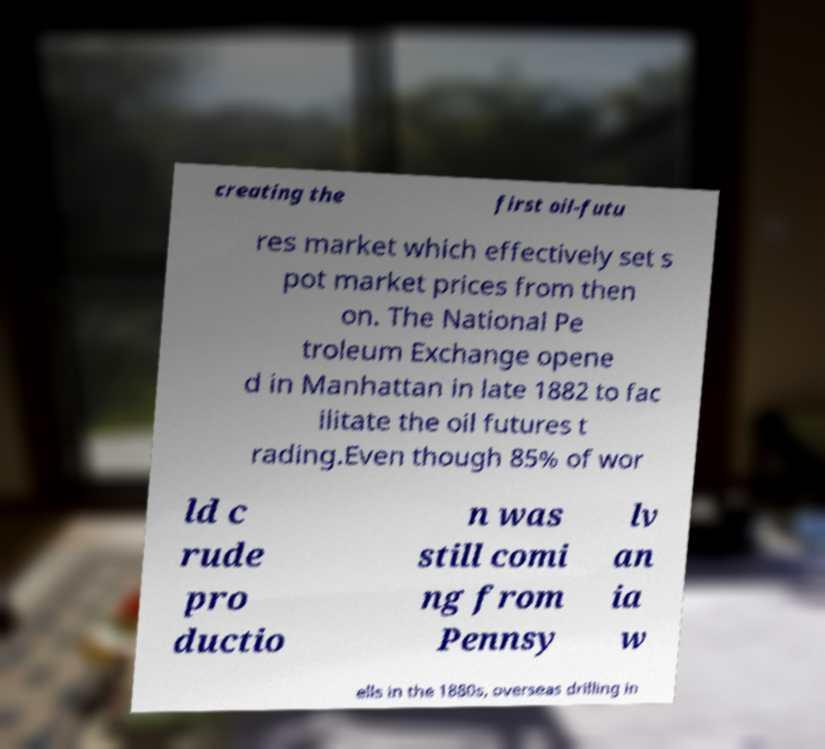Please read and relay the text visible in this image. What does it say? creating the first oil-futu res market which effectively set s pot market prices from then on. The National Pe troleum Exchange opene d in Manhattan in late 1882 to fac ilitate the oil futures t rading.Even though 85% of wor ld c rude pro ductio n was still comi ng from Pennsy lv an ia w ells in the 1880s, overseas drilling in 